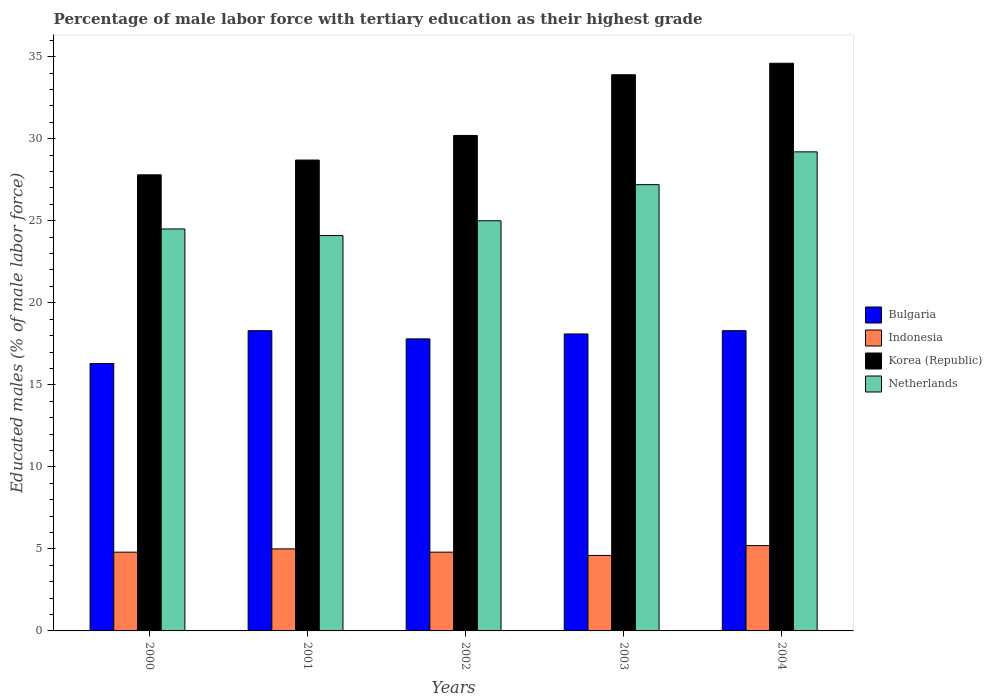How many different coloured bars are there?
Keep it short and to the point. 4. How many groups of bars are there?
Your answer should be compact. 5. How many bars are there on the 4th tick from the right?
Keep it short and to the point. 4. What is the label of the 2nd group of bars from the left?
Make the answer very short. 2001. What is the percentage of male labor force with tertiary education in Bulgaria in 2004?
Ensure brevity in your answer.  18.3. Across all years, what is the maximum percentage of male labor force with tertiary education in Netherlands?
Ensure brevity in your answer.  29.2. Across all years, what is the minimum percentage of male labor force with tertiary education in Indonesia?
Your answer should be compact. 4.6. In which year was the percentage of male labor force with tertiary education in Netherlands maximum?
Offer a terse response. 2004. In which year was the percentage of male labor force with tertiary education in Bulgaria minimum?
Your response must be concise. 2000. What is the total percentage of male labor force with tertiary education in Korea (Republic) in the graph?
Ensure brevity in your answer.  155.2. What is the difference between the percentage of male labor force with tertiary education in Netherlands in 2002 and that in 2004?
Your answer should be very brief. -4.2. What is the difference between the percentage of male labor force with tertiary education in Indonesia in 2000 and the percentage of male labor force with tertiary education in Bulgaria in 2003?
Offer a terse response. -13.3. What is the average percentage of male labor force with tertiary education in Bulgaria per year?
Provide a succinct answer. 17.76. In the year 2004, what is the difference between the percentage of male labor force with tertiary education in Bulgaria and percentage of male labor force with tertiary education in Netherlands?
Offer a terse response. -10.9. What is the ratio of the percentage of male labor force with tertiary education in Netherlands in 2002 to that in 2004?
Your answer should be compact. 0.86. What is the difference between the highest and the second highest percentage of male labor force with tertiary education in Indonesia?
Provide a short and direct response. 0.2. What is the difference between the highest and the lowest percentage of male labor force with tertiary education in Bulgaria?
Make the answer very short. 2. In how many years, is the percentage of male labor force with tertiary education in Korea (Republic) greater than the average percentage of male labor force with tertiary education in Korea (Republic) taken over all years?
Give a very brief answer. 2. Is it the case that in every year, the sum of the percentage of male labor force with tertiary education in Bulgaria and percentage of male labor force with tertiary education in Netherlands is greater than the sum of percentage of male labor force with tertiary education in Korea (Republic) and percentage of male labor force with tertiary education in Indonesia?
Ensure brevity in your answer.  No. What does the 1st bar from the left in 2003 represents?
Your answer should be compact. Bulgaria. Are all the bars in the graph horizontal?
Provide a succinct answer. No. How many years are there in the graph?
Make the answer very short. 5. Does the graph contain any zero values?
Your answer should be very brief. No. Does the graph contain grids?
Keep it short and to the point. No. How many legend labels are there?
Make the answer very short. 4. What is the title of the graph?
Make the answer very short. Percentage of male labor force with tertiary education as their highest grade. Does "Central African Republic" appear as one of the legend labels in the graph?
Keep it short and to the point. No. What is the label or title of the Y-axis?
Offer a terse response. Educated males (% of male labor force). What is the Educated males (% of male labor force) in Bulgaria in 2000?
Provide a short and direct response. 16.3. What is the Educated males (% of male labor force) in Indonesia in 2000?
Your answer should be compact. 4.8. What is the Educated males (% of male labor force) of Korea (Republic) in 2000?
Provide a succinct answer. 27.8. What is the Educated males (% of male labor force) in Bulgaria in 2001?
Provide a succinct answer. 18.3. What is the Educated males (% of male labor force) in Indonesia in 2001?
Give a very brief answer. 5. What is the Educated males (% of male labor force) of Korea (Republic) in 2001?
Give a very brief answer. 28.7. What is the Educated males (% of male labor force) of Netherlands in 2001?
Provide a short and direct response. 24.1. What is the Educated males (% of male labor force) in Bulgaria in 2002?
Keep it short and to the point. 17.8. What is the Educated males (% of male labor force) in Indonesia in 2002?
Ensure brevity in your answer.  4.8. What is the Educated males (% of male labor force) in Korea (Republic) in 2002?
Provide a short and direct response. 30.2. What is the Educated males (% of male labor force) in Netherlands in 2002?
Make the answer very short. 25. What is the Educated males (% of male labor force) in Bulgaria in 2003?
Provide a succinct answer. 18.1. What is the Educated males (% of male labor force) in Indonesia in 2003?
Offer a very short reply. 4.6. What is the Educated males (% of male labor force) of Korea (Republic) in 2003?
Ensure brevity in your answer.  33.9. What is the Educated males (% of male labor force) in Netherlands in 2003?
Offer a very short reply. 27.2. What is the Educated males (% of male labor force) in Bulgaria in 2004?
Provide a succinct answer. 18.3. What is the Educated males (% of male labor force) of Indonesia in 2004?
Offer a terse response. 5.2. What is the Educated males (% of male labor force) in Korea (Republic) in 2004?
Provide a short and direct response. 34.6. What is the Educated males (% of male labor force) in Netherlands in 2004?
Your answer should be very brief. 29.2. Across all years, what is the maximum Educated males (% of male labor force) in Bulgaria?
Provide a short and direct response. 18.3. Across all years, what is the maximum Educated males (% of male labor force) in Indonesia?
Ensure brevity in your answer.  5.2. Across all years, what is the maximum Educated males (% of male labor force) of Korea (Republic)?
Provide a succinct answer. 34.6. Across all years, what is the maximum Educated males (% of male labor force) in Netherlands?
Give a very brief answer. 29.2. Across all years, what is the minimum Educated males (% of male labor force) of Bulgaria?
Your response must be concise. 16.3. Across all years, what is the minimum Educated males (% of male labor force) in Indonesia?
Give a very brief answer. 4.6. Across all years, what is the minimum Educated males (% of male labor force) in Korea (Republic)?
Offer a very short reply. 27.8. Across all years, what is the minimum Educated males (% of male labor force) of Netherlands?
Give a very brief answer. 24.1. What is the total Educated males (% of male labor force) of Bulgaria in the graph?
Your response must be concise. 88.8. What is the total Educated males (% of male labor force) of Indonesia in the graph?
Your response must be concise. 24.4. What is the total Educated males (% of male labor force) in Korea (Republic) in the graph?
Keep it short and to the point. 155.2. What is the total Educated males (% of male labor force) of Netherlands in the graph?
Give a very brief answer. 130. What is the difference between the Educated males (% of male labor force) of Bulgaria in 2000 and that in 2001?
Provide a succinct answer. -2. What is the difference between the Educated males (% of male labor force) of Indonesia in 2000 and that in 2001?
Offer a terse response. -0.2. What is the difference between the Educated males (% of male labor force) in Bulgaria in 2000 and that in 2002?
Provide a short and direct response. -1.5. What is the difference between the Educated males (% of male labor force) in Korea (Republic) in 2000 and that in 2002?
Your response must be concise. -2.4. What is the difference between the Educated males (% of male labor force) of Netherlands in 2000 and that in 2002?
Provide a succinct answer. -0.5. What is the difference between the Educated males (% of male labor force) of Korea (Republic) in 2000 and that in 2003?
Your answer should be very brief. -6.1. What is the difference between the Educated males (% of male labor force) in Netherlands in 2000 and that in 2004?
Provide a short and direct response. -4.7. What is the difference between the Educated males (% of male labor force) of Bulgaria in 2001 and that in 2002?
Offer a very short reply. 0.5. What is the difference between the Educated males (% of male labor force) of Bulgaria in 2001 and that in 2003?
Your response must be concise. 0.2. What is the difference between the Educated males (% of male labor force) in Korea (Republic) in 2001 and that in 2003?
Make the answer very short. -5.2. What is the difference between the Educated males (% of male labor force) of Netherlands in 2001 and that in 2003?
Your answer should be compact. -3.1. What is the difference between the Educated males (% of male labor force) in Indonesia in 2001 and that in 2004?
Keep it short and to the point. -0.2. What is the difference between the Educated males (% of male labor force) in Netherlands in 2001 and that in 2004?
Offer a terse response. -5.1. What is the difference between the Educated males (% of male labor force) in Korea (Republic) in 2002 and that in 2003?
Offer a terse response. -3.7. What is the difference between the Educated males (% of male labor force) in Netherlands in 2002 and that in 2003?
Offer a terse response. -2.2. What is the difference between the Educated males (% of male labor force) in Indonesia in 2002 and that in 2004?
Your answer should be very brief. -0.4. What is the difference between the Educated males (% of male labor force) in Bulgaria in 2003 and that in 2004?
Give a very brief answer. -0.2. What is the difference between the Educated males (% of male labor force) of Indonesia in 2003 and that in 2004?
Your answer should be very brief. -0.6. What is the difference between the Educated males (% of male labor force) in Bulgaria in 2000 and the Educated males (% of male labor force) in Korea (Republic) in 2001?
Your answer should be very brief. -12.4. What is the difference between the Educated males (% of male labor force) of Indonesia in 2000 and the Educated males (% of male labor force) of Korea (Republic) in 2001?
Your answer should be compact. -23.9. What is the difference between the Educated males (% of male labor force) of Indonesia in 2000 and the Educated males (% of male labor force) of Netherlands in 2001?
Make the answer very short. -19.3. What is the difference between the Educated males (% of male labor force) of Bulgaria in 2000 and the Educated males (% of male labor force) of Indonesia in 2002?
Keep it short and to the point. 11.5. What is the difference between the Educated males (% of male labor force) of Bulgaria in 2000 and the Educated males (% of male labor force) of Netherlands in 2002?
Your answer should be very brief. -8.7. What is the difference between the Educated males (% of male labor force) in Indonesia in 2000 and the Educated males (% of male labor force) in Korea (Republic) in 2002?
Offer a terse response. -25.4. What is the difference between the Educated males (% of male labor force) of Indonesia in 2000 and the Educated males (% of male labor force) of Netherlands in 2002?
Make the answer very short. -20.2. What is the difference between the Educated males (% of male labor force) of Bulgaria in 2000 and the Educated males (% of male labor force) of Indonesia in 2003?
Provide a short and direct response. 11.7. What is the difference between the Educated males (% of male labor force) in Bulgaria in 2000 and the Educated males (% of male labor force) in Korea (Republic) in 2003?
Offer a very short reply. -17.6. What is the difference between the Educated males (% of male labor force) in Indonesia in 2000 and the Educated males (% of male labor force) in Korea (Republic) in 2003?
Give a very brief answer. -29.1. What is the difference between the Educated males (% of male labor force) in Indonesia in 2000 and the Educated males (% of male labor force) in Netherlands in 2003?
Offer a terse response. -22.4. What is the difference between the Educated males (% of male labor force) in Korea (Republic) in 2000 and the Educated males (% of male labor force) in Netherlands in 2003?
Give a very brief answer. 0.6. What is the difference between the Educated males (% of male labor force) of Bulgaria in 2000 and the Educated males (% of male labor force) of Korea (Republic) in 2004?
Your response must be concise. -18.3. What is the difference between the Educated males (% of male labor force) of Bulgaria in 2000 and the Educated males (% of male labor force) of Netherlands in 2004?
Your response must be concise. -12.9. What is the difference between the Educated males (% of male labor force) in Indonesia in 2000 and the Educated males (% of male labor force) in Korea (Republic) in 2004?
Make the answer very short. -29.8. What is the difference between the Educated males (% of male labor force) in Indonesia in 2000 and the Educated males (% of male labor force) in Netherlands in 2004?
Your answer should be very brief. -24.4. What is the difference between the Educated males (% of male labor force) in Korea (Republic) in 2000 and the Educated males (% of male labor force) in Netherlands in 2004?
Offer a very short reply. -1.4. What is the difference between the Educated males (% of male labor force) of Indonesia in 2001 and the Educated males (% of male labor force) of Korea (Republic) in 2002?
Give a very brief answer. -25.2. What is the difference between the Educated males (% of male labor force) of Bulgaria in 2001 and the Educated males (% of male labor force) of Indonesia in 2003?
Make the answer very short. 13.7. What is the difference between the Educated males (% of male labor force) of Bulgaria in 2001 and the Educated males (% of male labor force) of Korea (Republic) in 2003?
Make the answer very short. -15.6. What is the difference between the Educated males (% of male labor force) in Bulgaria in 2001 and the Educated males (% of male labor force) in Netherlands in 2003?
Offer a very short reply. -8.9. What is the difference between the Educated males (% of male labor force) of Indonesia in 2001 and the Educated males (% of male labor force) of Korea (Republic) in 2003?
Your response must be concise. -28.9. What is the difference between the Educated males (% of male labor force) in Indonesia in 2001 and the Educated males (% of male labor force) in Netherlands in 2003?
Your answer should be compact. -22.2. What is the difference between the Educated males (% of male labor force) of Bulgaria in 2001 and the Educated males (% of male labor force) of Indonesia in 2004?
Your answer should be compact. 13.1. What is the difference between the Educated males (% of male labor force) in Bulgaria in 2001 and the Educated males (% of male labor force) in Korea (Republic) in 2004?
Provide a short and direct response. -16.3. What is the difference between the Educated males (% of male labor force) in Indonesia in 2001 and the Educated males (% of male labor force) in Korea (Republic) in 2004?
Give a very brief answer. -29.6. What is the difference between the Educated males (% of male labor force) of Indonesia in 2001 and the Educated males (% of male labor force) of Netherlands in 2004?
Offer a terse response. -24.2. What is the difference between the Educated males (% of male labor force) of Korea (Republic) in 2001 and the Educated males (% of male labor force) of Netherlands in 2004?
Your answer should be very brief. -0.5. What is the difference between the Educated males (% of male labor force) of Bulgaria in 2002 and the Educated males (% of male labor force) of Korea (Republic) in 2003?
Ensure brevity in your answer.  -16.1. What is the difference between the Educated males (% of male labor force) in Indonesia in 2002 and the Educated males (% of male labor force) in Korea (Republic) in 2003?
Your response must be concise. -29.1. What is the difference between the Educated males (% of male labor force) of Indonesia in 2002 and the Educated males (% of male labor force) of Netherlands in 2003?
Ensure brevity in your answer.  -22.4. What is the difference between the Educated males (% of male labor force) of Korea (Republic) in 2002 and the Educated males (% of male labor force) of Netherlands in 2003?
Ensure brevity in your answer.  3. What is the difference between the Educated males (% of male labor force) in Bulgaria in 2002 and the Educated males (% of male labor force) in Korea (Republic) in 2004?
Give a very brief answer. -16.8. What is the difference between the Educated males (% of male labor force) in Indonesia in 2002 and the Educated males (% of male labor force) in Korea (Republic) in 2004?
Your response must be concise. -29.8. What is the difference between the Educated males (% of male labor force) of Indonesia in 2002 and the Educated males (% of male labor force) of Netherlands in 2004?
Your response must be concise. -24.4. What is the difference between the Educated males (% of male labor force) in Korea (Republic) in 2002 and the Educated males (% of male labor force) in Netherlands in 2004?
Keep it short and to the point. 1. What is the difference between the Educated males (% of male labor force) in Bulgaria in 2003 and the Educated males (% of male labor force) in Korea (Republic) in 2004?
Provide a succinct answer. -16.5. What is the difference between the Educated males (% of male labor force) of Indonesia in 2003 and the Educated males (% of male labor force) of Netherlands in 2004?
Your answer should be very brief. -24.6. What is the average Educated males (% of male labor force) in Bulgaria per year?
Make the answer very short. 17.76. What is the average Educated males (% of male labor force) of Indonesia per year?
Your response must be concise. 4.88. What is the average Educated males (% of male labor force) of Korea (Republic) per year?
Your response must be concise. 31.04. In the year 2000, what is the difference between the Educated males (% of male labor force) in Bulgaria and Educated males (% of male labor force) in Netherlands?
Your answer should be very brief. -8.2. In the year 2000, what is the difference between the Educated males (% of male labor force) of Indonesia and Educated males (% of male labor force) of Netherlands?
Provide a succinct answer. -19.7. In the year 2000, what is the difference between the Educated males (% of male labor force) in Korea (Republic) and Educated males (% of male labor force) in Netherlands?
Offer a very short reply. 3.3. In the year 2001, what is the difference between the Educated males (% of male labor force) of Bulgaria and Educated males (% of male labor force) of Indonesia?
Provide a succinct answer. 13.3. In the year 2001, what is the difference between the Educated males (% of male labor force) in Bulgaria and Educated males (% of male labor force) in Korea (Republic)?
Give a very brief answer. -10.4. In the year 2001, what is the difference between the Educated males (% of male labor force) in Indonesia and Educated males (% of male labor force) in Korea (Republic)?
Offer a very short reply. -23.7. In the year 2001, what is the difference between the Educated males (% of male labor force) of Indonesia and Educated males (% of male labor force) of Netherlands?
Make the answer very short. -19.1. In the year 2001, what is the difference between the Educated males (% of male labor force) in Korea (Republic) and Educated males (% of male labor force) in Netherlands?
Provide a short and direct response. 4.6. In the year 2002, what is the difference between the Educated males (% of male labor force) in Indonesia and Educated males (% of male labor force) in Korea (Republic)?
Your response must be concise. -25.4. In the year 2002, what is the difference between the Educated males (% of male labor force) of Indonesia and Educated males (% of male labor force) of Netherlands?
Provide a succinct answer. -20.2. In the year 2002, what is the difference between the Educated males (% of male labor force) of Korea (Republic) and Educated males (% of male labor force) of Netherlands?
Your answer should be compact. 5.2. In the year 2003, what is the difference between the Educated males (% of male labor force) in Bulgaria and Educated males (% of male labor force) in Korea (Republic)?
Your response must be concise. -15.8. In the year 2003, what is the difference between the Educated males (% of male labor force) of Indonesia and Educated males (% of male labor force) of Korea (Republic)?
Your answer should be very brief. -29.3. In the year 2003, what is the difference between the Educated males (% of male labor force) in Indonesia and Educated males (% of male labor force) in Netherlands?
Your answer should be very brief. -22.6. In the year 2004, what is the difference between the Educated males (% of male labor force) in Bulgaria and Educated males (% of male labor force) in Indonesia?
Make the answer very short. 13.1. In the year 2004, what is the difference between the Educated males (% of male labor force) in Bulgaria and Educated males (% of male labor force) in Korea (Republic)?
Give a very brief answer. -16.3. In the year 2004, what is the difference between the Educated males (% of male labor force) of Indonesia and Educated males (% of male labor force) of Korea (Republic)?
Give a very brief answer. -29.4. In the year 2004, what is the difference between the Educated males (% of male labor force) of Korea (Republic) and Educated males (% of male labor force) of Netherlands?
Keep it short and to the point. 5.4. What is the ratio of the Educated males (% of male labor force) of Bulgaria in 2000 to that in 2001?
Your answer should be very brief. 0.89. What is the ratio of the Educated males (% of male labor force) of Indonesia in 2000 to that in 2001?
Provide a succinct answer. 0.96. What is the ratio of the Educated males (% of male labor force) in Korea (Republic) in 2000 to that in 2001?
Your answer should be very brief. 0.97. What is the ratio of the Educated males (% of male labor force) of Netherlands in 2000 to that in 2001?
Ensure brevity in your answer.  1.02. What is the ratio of the Educated males (% of male labor force) in Bulgaria in 2000 to that in 2002?
Ensure brevity in your answer.  0.92. What is the ratio of the Educated males (% of male labor force) in Korea (Republic) in 2000 to that in 2002?
Provide a short and direct response. 0.92. What is the ratio of the Educated males (% of male labor force) of Netherlands in 2000 to that in 2002?
Provide a short and direct response. 0.98. What is the ratio of the Educated males (% of male labor force) of Bulgaria in 2000 to that in 2003?
Offer a terse response. 0.9. What is the ratio of the Educated males (% of male labor force) of Indonesia in 2000 to that in 2003?
Your response must be concise. 1.04. What is the ratio of the Educated males (% of male labor force) of Korea (Republic) in 2000 to that in 2003?
Provide a succinct answer. 0.82. What is the ratio of the Educated males (% of male labor force) in Netherlands in 2000 to that in 2003?
Provide a succinct answer. 0.9. What is the ratio of the Educated males (% of male labor force) in Bulgaria in 2000 to that in 2004?
Offer a very short reply. 0.89. What is the ratio of the Educated males (% of male labor force) of Indonesia in 2000 to that in 2004?
Your answer should be very brief. 0.92. What is the ratio of the Educated males (% of male labor force) of Korea (Republic) in 2000 to that in 2004?
Your answer should be compact. 0.8. What is the ratio of the Educated males (% of male labor force) of Netherlands in 2000 to that in 2004?
Offer a very short reply. 0.84. What is the ratio of the Educated males (% of male labor force) in Bulgaria in 2001 to that in 2002?
Make the answer very short. 1.03. What is the ratio of the Educated males (% of male labor force) of Indonesia in 2001 to that in 2002?
Offer a terse response. 1.04. What is the ratio of the Educated males (% of male labor force) in Korea (Republic) in 2001 to that in 2002?
Ensure brevity in your answer.  0.95. What is the ratio of the Educated males (% of male labor force) of Bulgaria in 2001 to that in 2003?
Provide a short and direct response. 1.01. What is the ratio of the Educated males (% of male labor force) in Indonesia in 2001 to that in 2003?
Provide a succinct answer. 1.09. What is the ratio of the Educated males (% of male labor force) of Korea (Republic) in 2001 to that in 2003?
Offer a terse response. 0.85. What is the ratio of the Educated males (% of male labor force) of Netherlands in 2001 to that in 2003?
Provide a succinct answer. 0.89. What is the ratio of the Educated males (% of male labor force) in Bulgaria in 2001 to that in 2004?
Your answer should be very brief. 1. What is the ratio of the Educated males (% of male labor force) of Indonesia in 2001 to that in 2004?
Ensure brevity in your answer.  0.96. What is the ratio of the Educated males (% of male labor force) of Korea (Republic) in 2001 to that in 2004?
Make the answer very short. 0.83. What is the ratio of the Educated males (% of male labor force) in Netherlands in 2001 to that in 2004?
Provide a succinct answer. 0.83. What is the ratio of the Educated males (% of male labor force) of Bulgaria in 2002 to that in 2003?
Provide a short and direct response. 0.98. What is the ratio of the Educated males (% of male labor force) in Indonesia in 2002 to that in 2003?
Offer a very short reply. 1.04. What is the ratio of the Educated males (% of male labor force) of Korea (Republic) in 2002 to that in 2003?
Provide a short and direct response. 0.89. What is the ratio of the Educated males (% of male labor force) in Netherlands in 2002 to that in 2003?
Give a very brief answer. 0.92. What is the ratio of the Educated males (% of male labor force) of Bulgaria in 2002 to that in 2004?
Your answer should be compact. 0.97. What is the ratio of the Educated males (% of male labor force) in Indonesia in 2002 to that in 2004?
Your response must be concise. 0.92. What is the ratio of the Educated males (% of male labor force) in Korea (Republic) in 2002 to that in 2004?
Provide a succinct answer. 0.87. What is the ratio of the Educated males (% of male labor force) in Netherlands in 2002 to that in 2004?
Provide a short and direct response. 0.86. What is the ratio of the Educated males (% of male labor force) in Indonesia in 2003 to that in 2004?
Give a very brief answer. 0.88. What is the ratio of the Educated males (% of male labor force) in Korea (Republic) in 2003 to that in 2004?
Make the answer very short. 0.98. What is the ratio of the Educated males (% of male labor force) in Netherlands in 2003 to that in 2004?
Give a very brief answer. 0.93. What is the difference between the highest and the second highest Educated males (% of male labor force) in Bulgaria?
Provide a short and direct response. 0. What is the difference between the highest and the second highest Educated males (% of male labor force) of Korea (Republic)?
Offer a terse response. 0.7. What is the difference between the highest and the second highest Educated males (% of male labor force) of Netherlands?
Give a very brief answer. 2. What is the difference between the highest and the lowest Educated males (% of male labor force) in Bulgaria?
Provide a short and direct response. 2. 